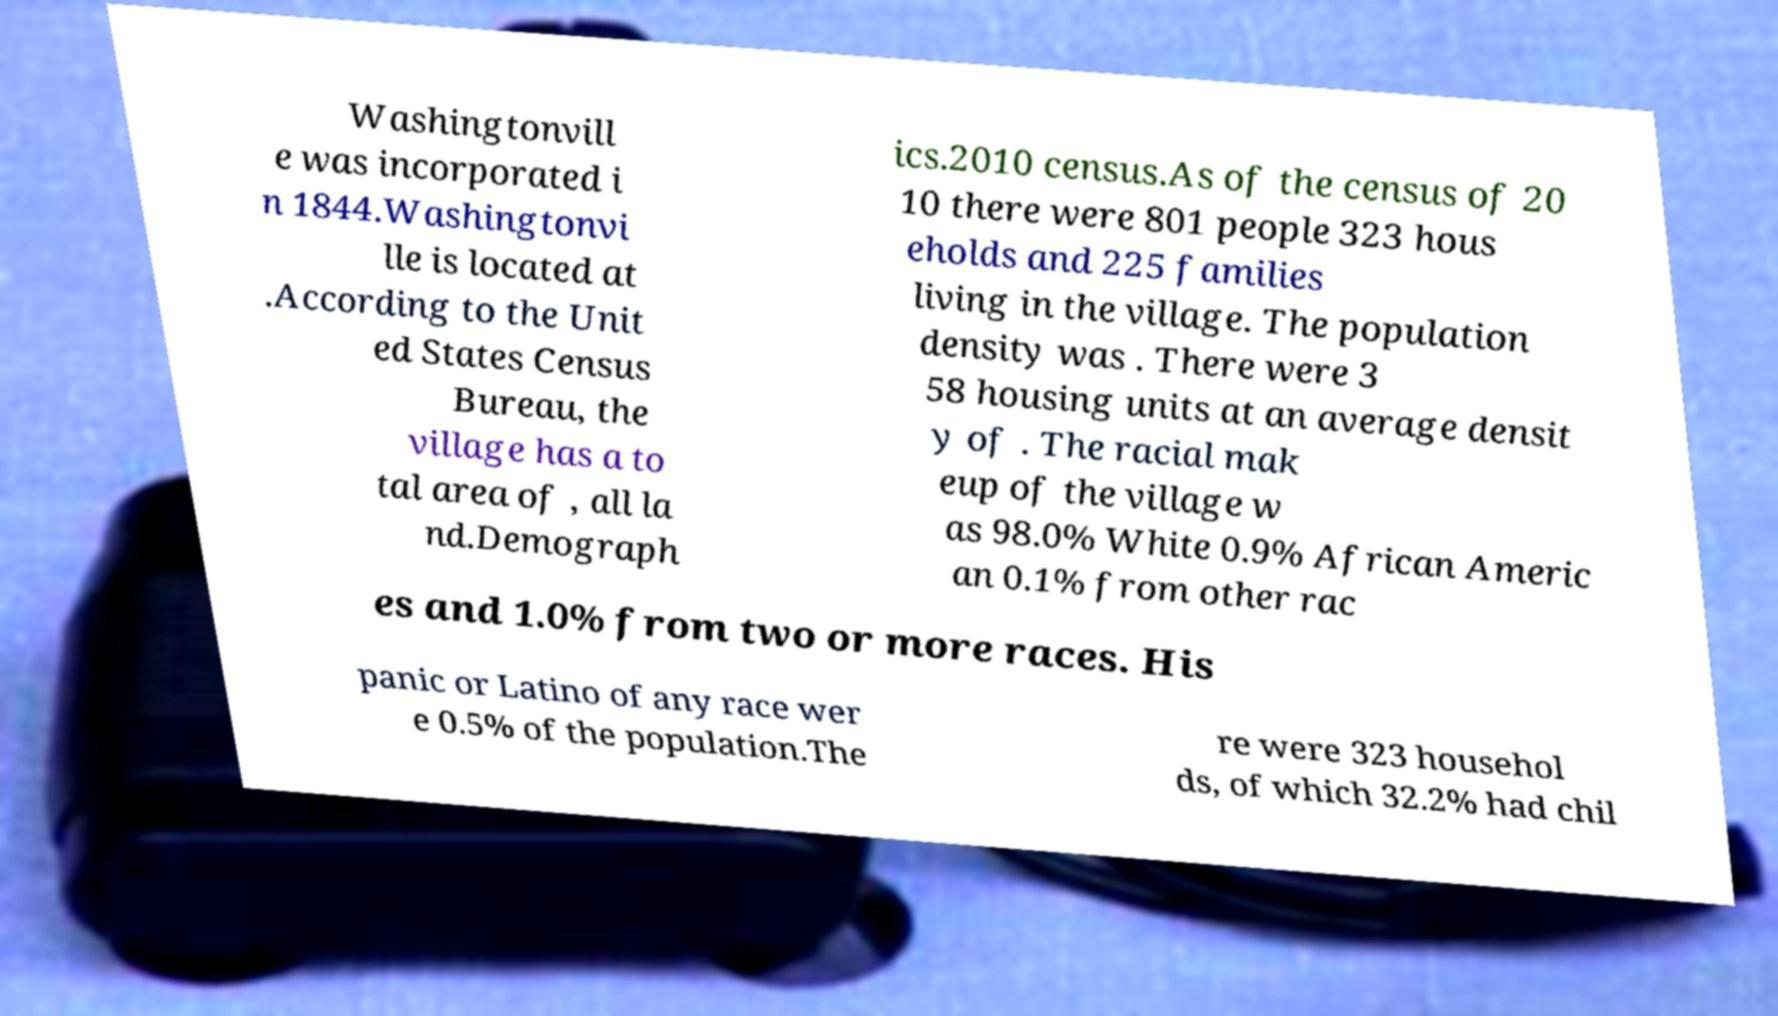What messages or text are displayed in this image? I need them in a readable, typed format. Washingtonvill e was incorporated i n 1844.Washingtonvi lle is located at .According to the Unit ed States Census Bureau, the village has a to tal area of , all la nd.Demograph ics.2010 census.As of the census of 20 10 there were 801 people 323 hous eholds and 225 families living in the village. The population density was . There were 3 58 housing units at an average densit y of . The racial mak eup of the village w as 98.0% White 0.9% African Americ an 0.1% from other rac es and 1.0% from two or more races. His panic or Latino of any race wer e 0.5% of the population.The re were 323 househol ds, of which 32.2% had chil 